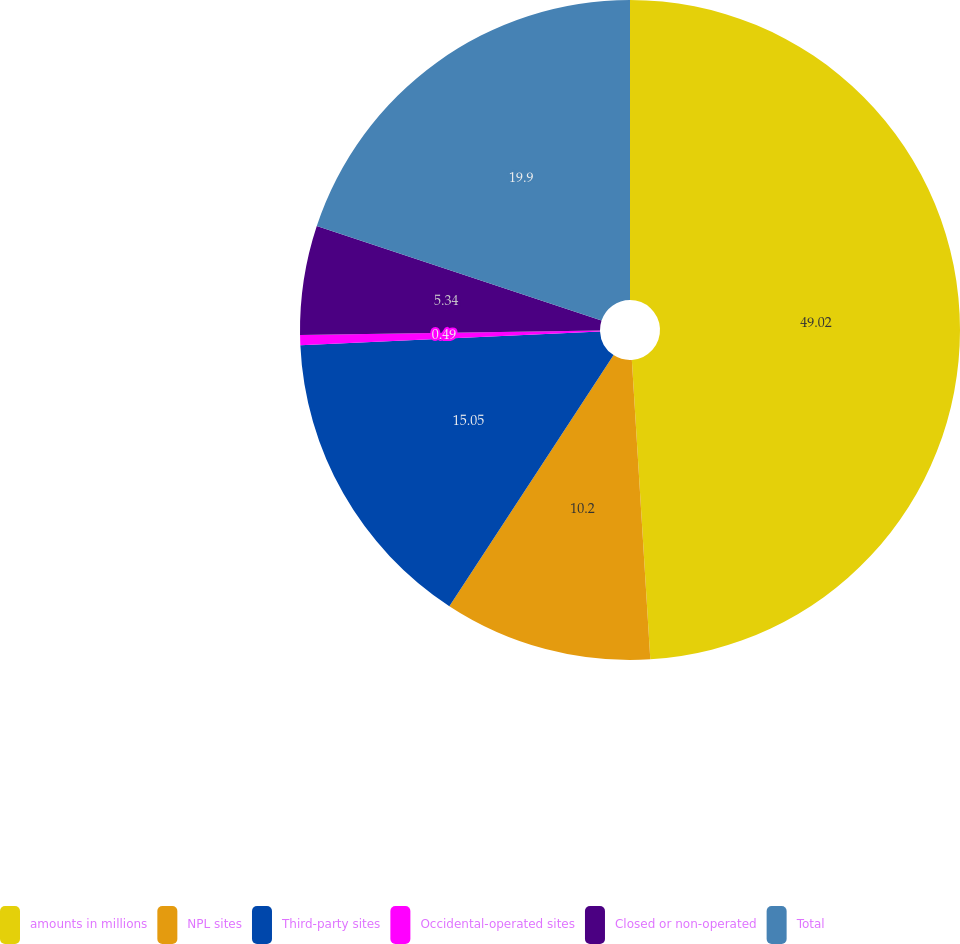<chart> <loc_0><loc_0><loc_500><loc_500><pie_chart><fcel>amounts in millions<fcel>NPL sites<fcel>Third-party sites<fcel>Occidental-operated sites<fcel>Closed or non-operated<fcel>Total<nl><fcel>49.02%<fcel>10.2%<fcel>15.05%<fcel>0.49%<fcel>5.34%<fcel>19.9%<nl></chart> 